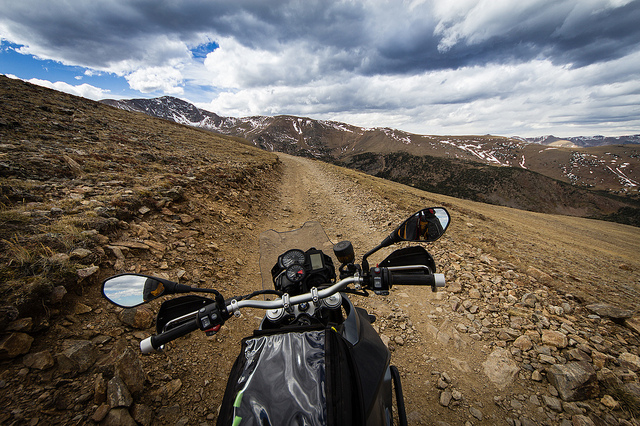Could this image have been taken during a special time of the year? Given the remaining snow on the distant mountains and the absence of lush vegetation, it's plausible that the image was captured either in late spring when the snow is still melting or in early fall when the first snows have begun to settle. 